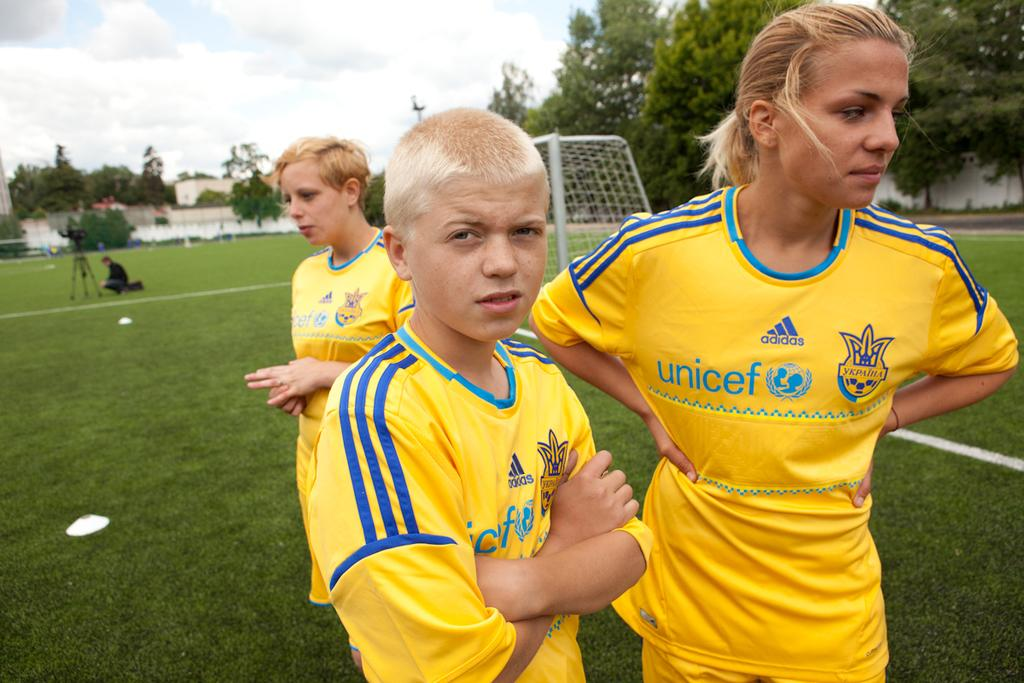<image>
Summarize the visual content of the image. yellow jerseys with the word unicef on it 